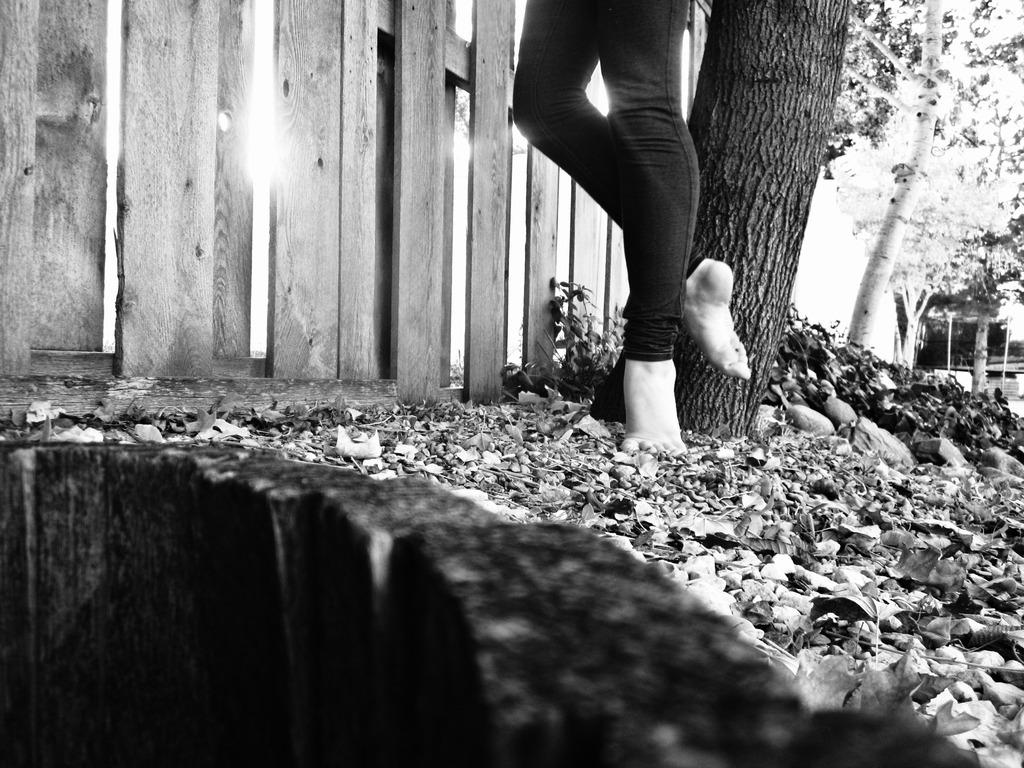What type of wooden object can be seen in the image? There is a wooden object in the image, but the specific type is not mentioned. What other natural elements are present in the image? There are stones, dry leaves, a tree trunk, and shrubs visible in the image. Can you describe the person's legs in the image? A person's legs are visible in the image, but no further details about the person are provided. What type of barrier is present in the image? There is a wooden fence in the image. What is visible in the background of the image? Trees are present in the background of the image. Which direction is the ring pointing towards in the image? There is no ring present in the image. What is the body's position in the image? The body's position is not mentioned in the image, only the person's legs are visible. 